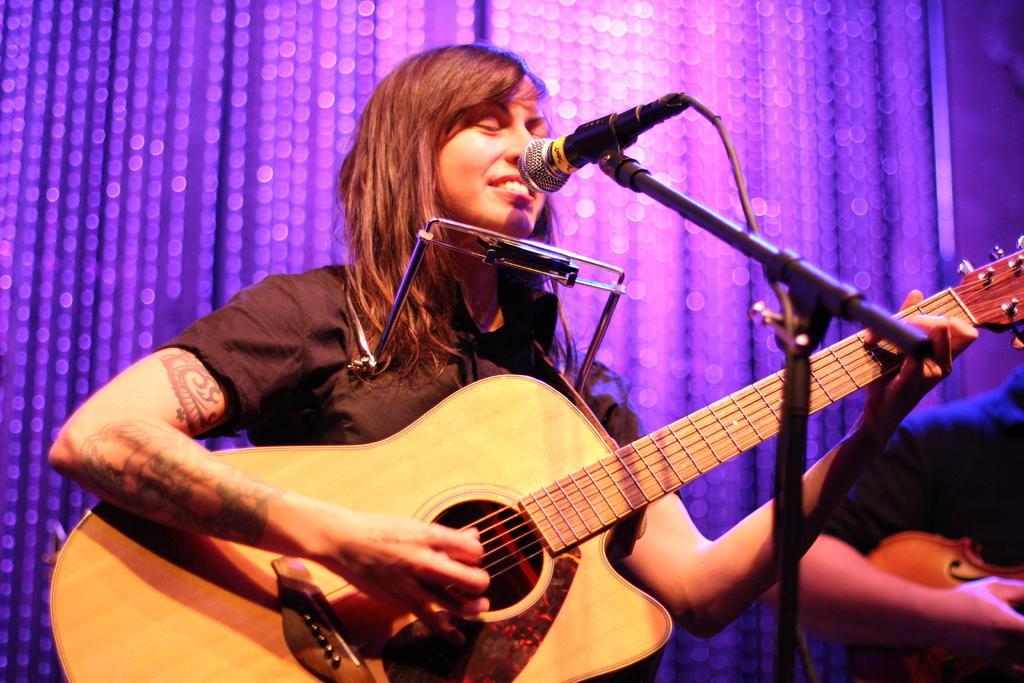Could you give a brief overview of what you see in this image? A woman is smiling and playing a guitar. In the background there is a crystal wall with lights. On the right a person playing another musical instrument. In front of her there is a mic and mic stand. 